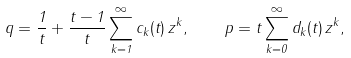Convert formula to latex. <formula><loc_0><loc_0><loc_500><loc_500>q = \frac { 1 } { t } + \frac { t - 1 } { t } \sum _ { k = 1 } ^ { \infty } c _ { k } ( t ) \, z ^ { k } , \quad p = t \sum _ { k = 0 } ^ { \infty } d _ { k } ( t ) \, z ^ { k } ,</formula> 